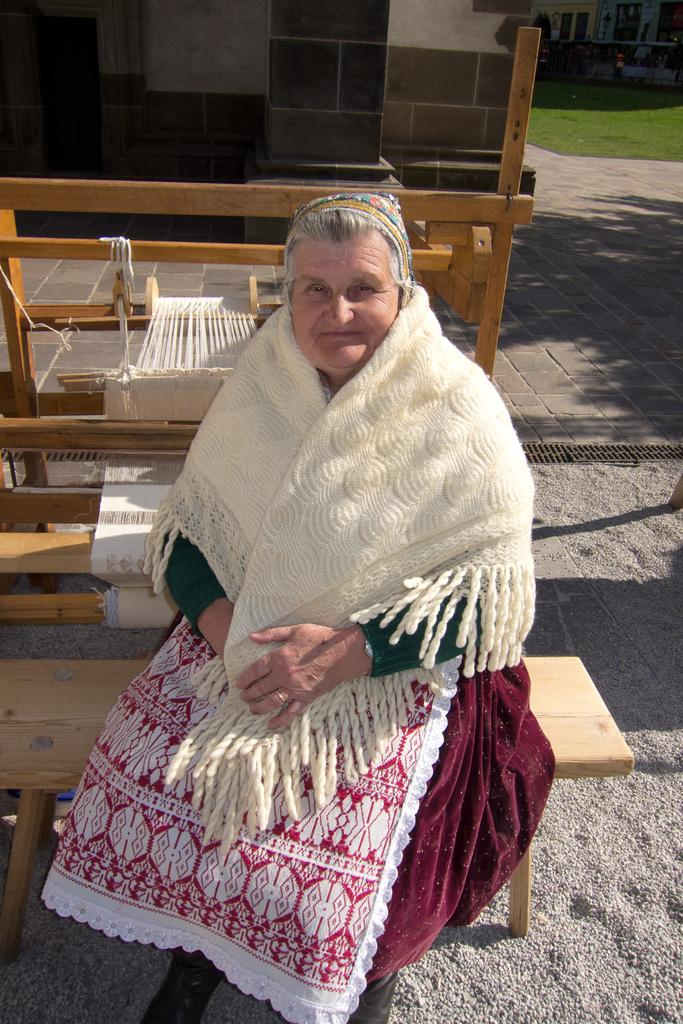What is the woman in the image doing? The woman is sitting on a bench in the image. What is the woman's facial expression in the image? The woman is smiling in the image. What can be seen in the background of the image? There is a wall, woods, and grass in the background of the image. What is the price of the wave in the image? There is no wave present in the image, so it is not possible to determine its price. 